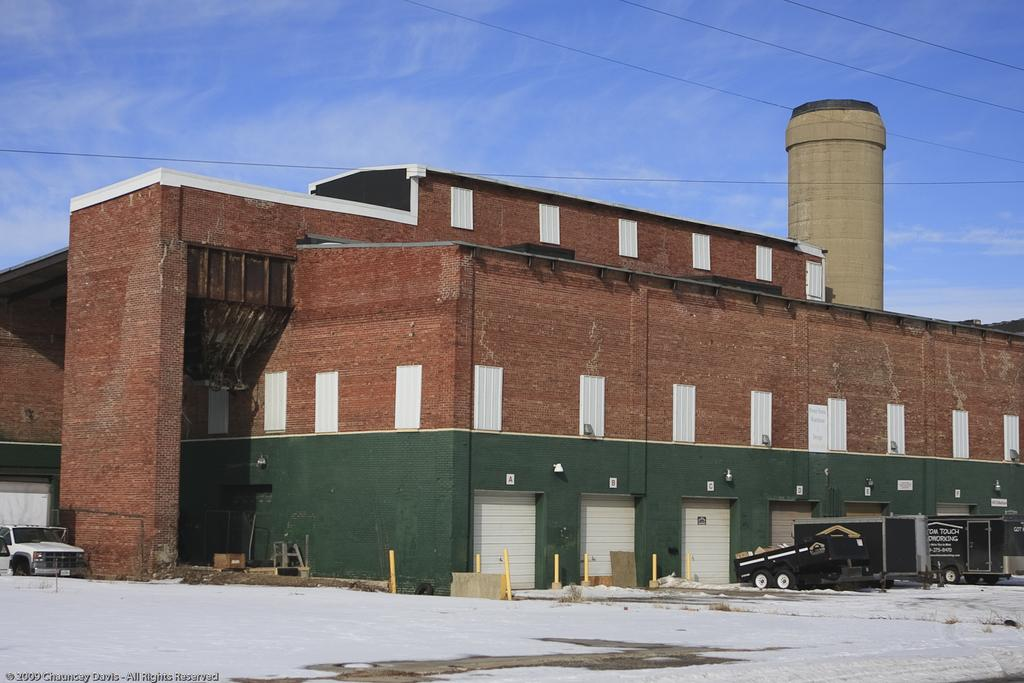What types of vehicles are on the ground in the image? There are vehicles on the ground in the image, but the specific types are not mentioned. What structures can be seen in the image? There are poles and a building visible in the image. What is the weather like in the image? There is snow visible in the image, indicating a cold or wintry environment. What else can be seen in the image besides the vehicles and structures? There are wires and some objects present in the image. What is visible in the background of the image? The sky is visible in the background of the image, and clouds are present in the sky. Can you see a boot hanging from the wires in the image? There is no mention of a boot in the image, so it cannot be seen hanging from the wires. What type of circle is present in the image? There is no mention of a circle in the image, so it cannot be described. 